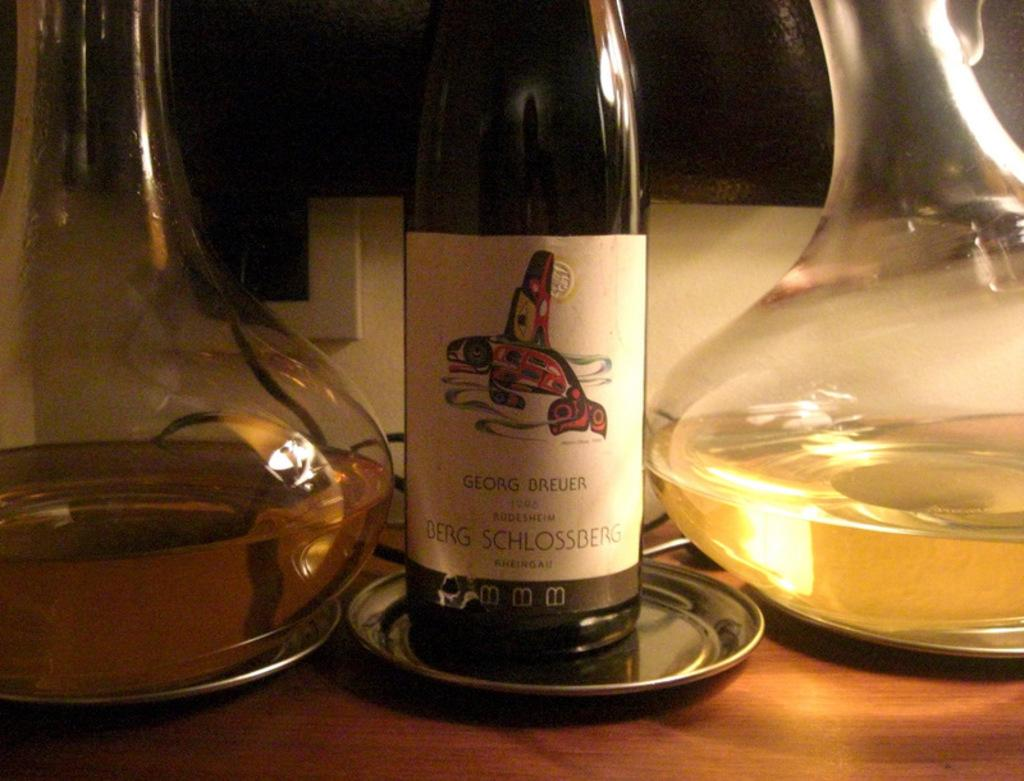<image>
Provide a brief description of the given image. A bottle bears the name Georg Breuer and the year 1995. 